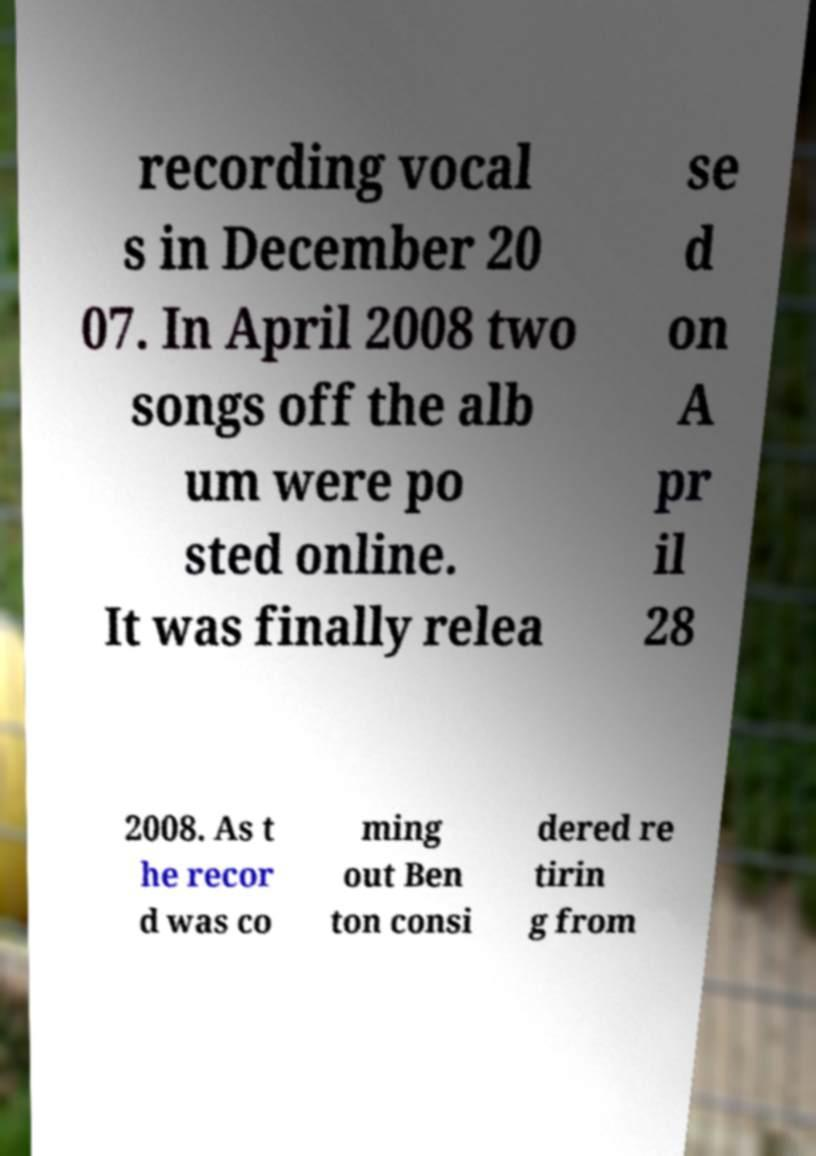Can you accurately transcribe the text from the provided image for me? recording vocal s in December 20 07. In April 2008 two songs off the alb um were po sted online. It was finally relea se d on A pr il 28 2008. As t he recor d was co ming out Ben ton consi dered re tirin g from 